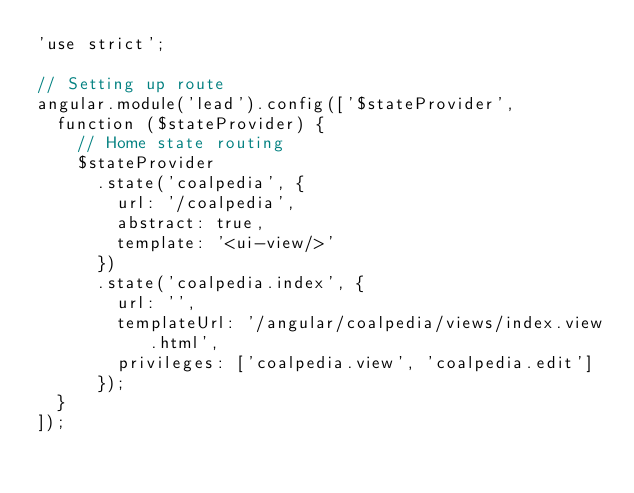Convert code to text. <code><loc_0><loc_0><loc_500><loc_500><_JavaScript_>'use strict';

// Setting up route
angular.module('lead').config(['$stateProvider',
  function ($stateProvider) {
    // Home state routing
    $stateProvider
      .state('coalpedia', {
        url: '/coalpedia',
        abstract: true,
        template: '<ui-view/>'
      })
      .state('coalpedia.index', {
        url: '',
        templateUrl: '/angular/coalpedia/views/index.view.html',
        privileges: ['coalpedia.view', 'coalpedia.edit']
      });
  }
]);
</code> 